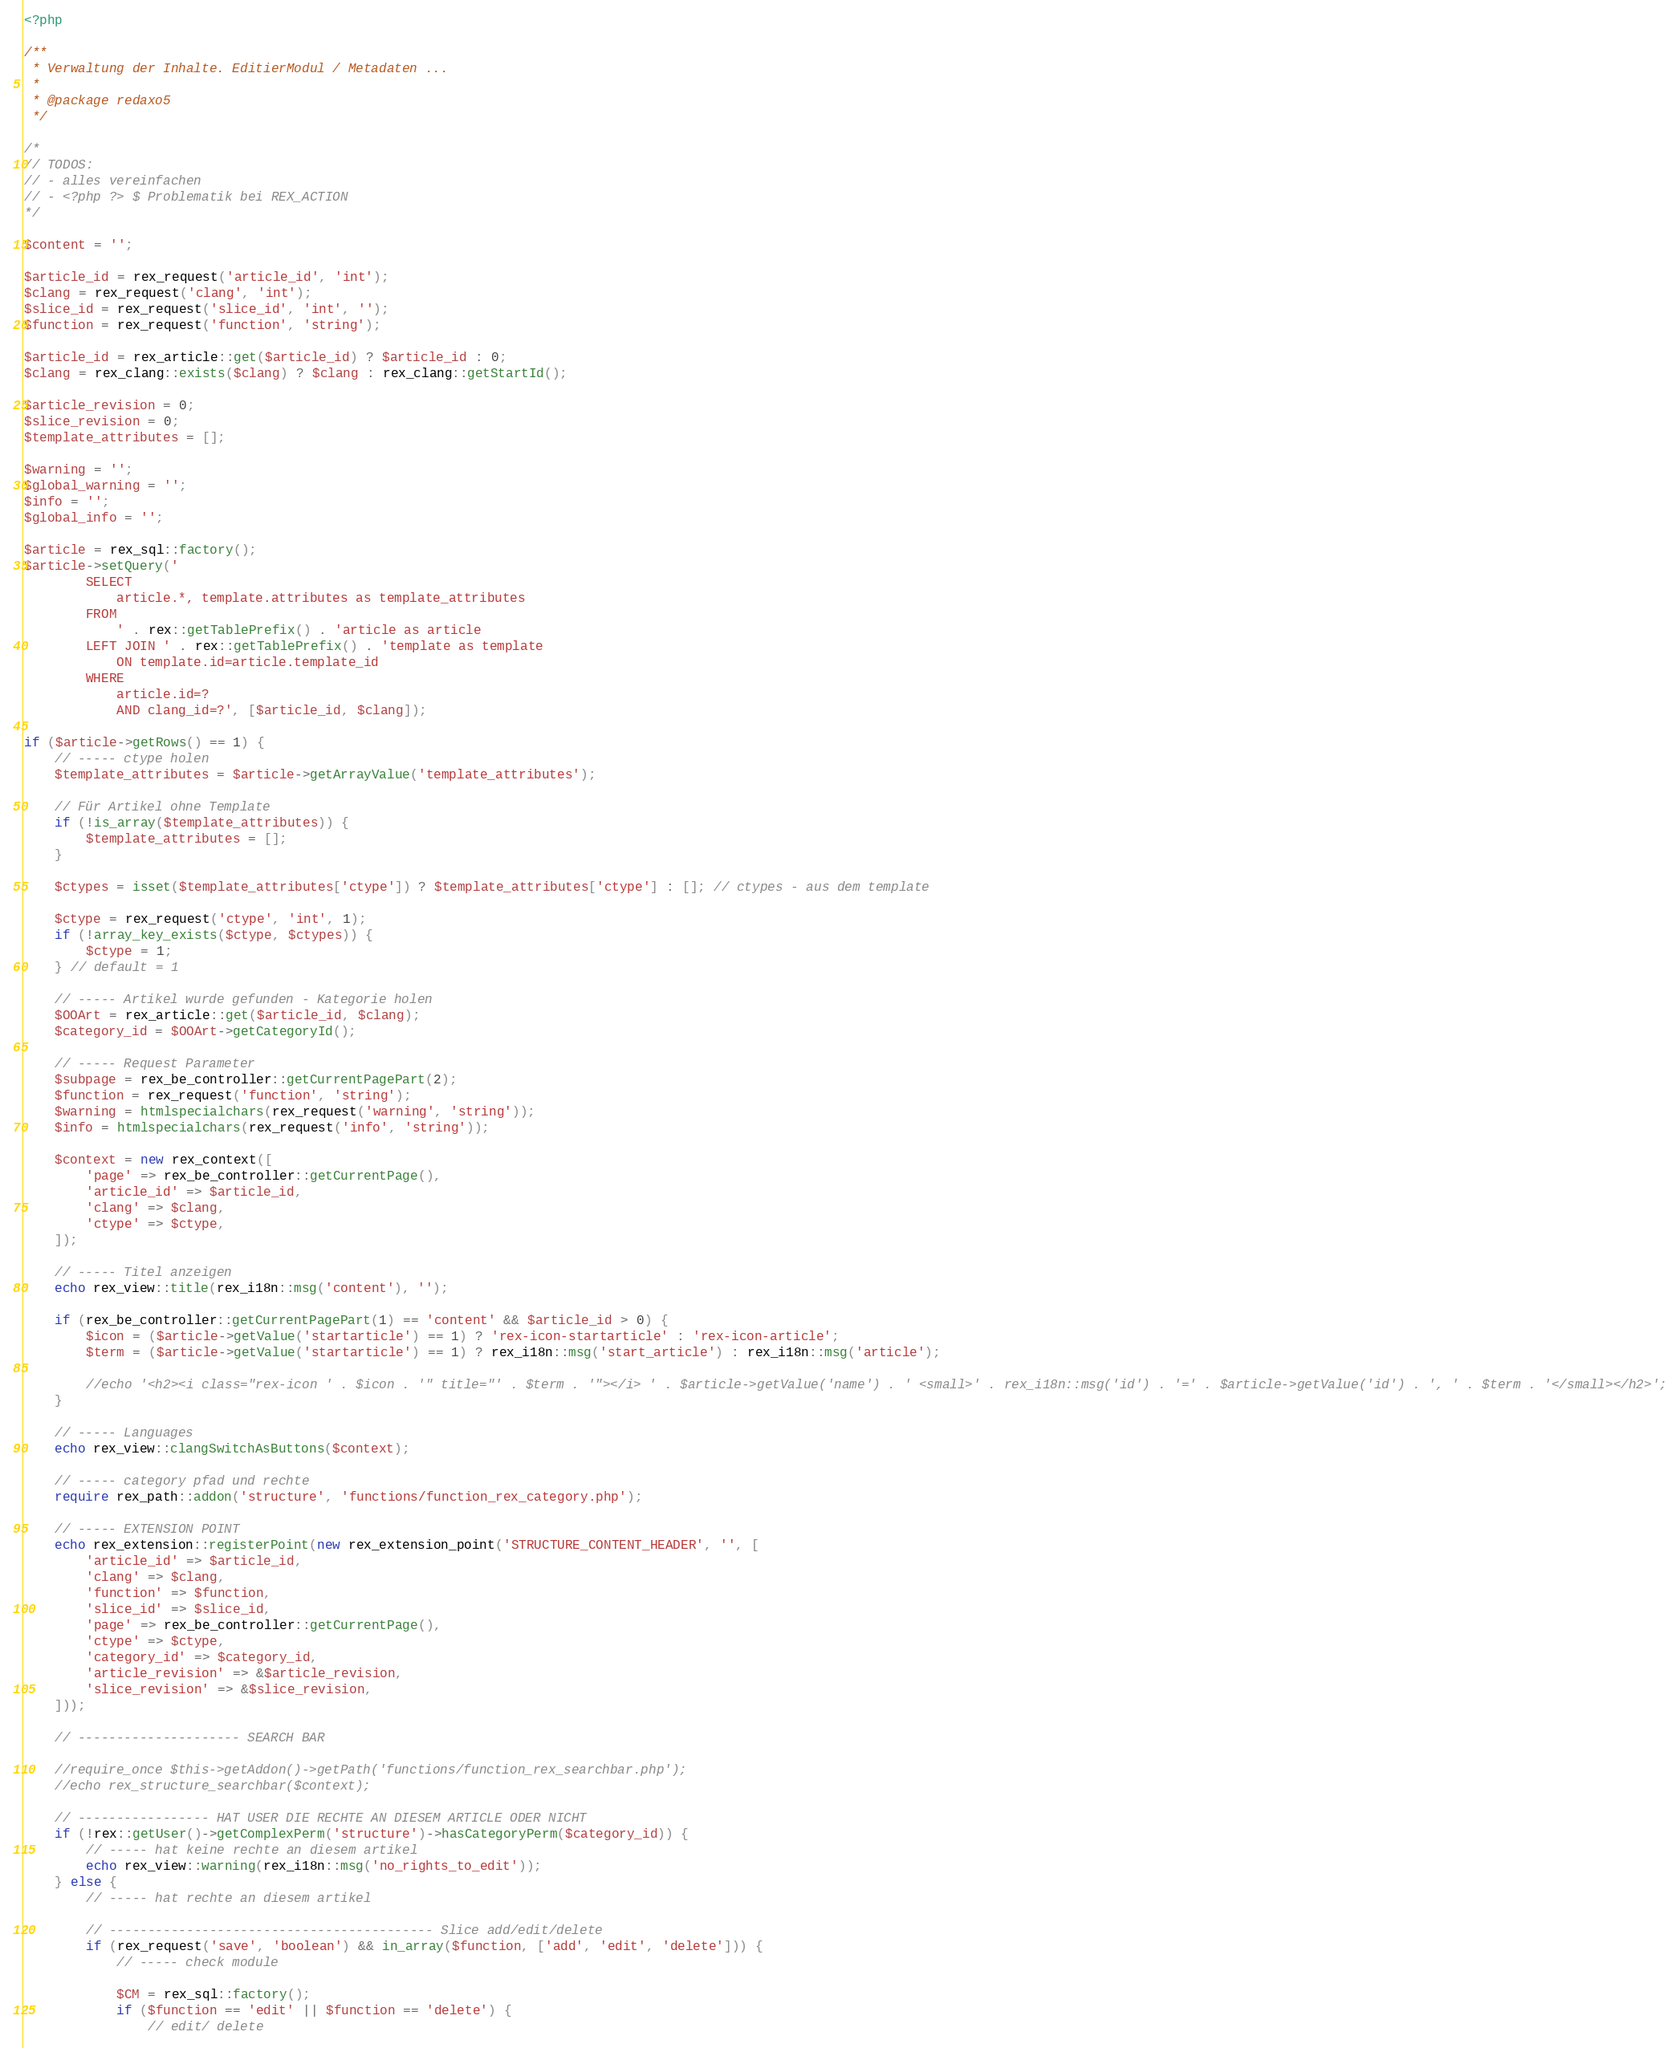Convert code to text. <code><loc_0><loc_0><loc_500><loc_500><_PHP_><?php

/**
 * Verwaltung der Inhalte. EditierModul / Metadaten ...
 *
 * @package redaxo5
 */

/*
// TODOS:
// - alles vereinfachen
// - <?php ?> $ Problematik bei REX_ACTION
*/

$content = '';

$article_id = rex_request('article_id', 'int');
$clang = rex_request('clang', 'int');
$slice_id = rex_request('slice_id', 'int', '');
$function = rex_request('function', 'string');

$article_id = rex_article::get($article_id) ? $article_id : 0;
$clang = rex_clang::exists($clang) ? $clang : rex_clang::getStartId();

$article_revision = 0;
$slice_revision = 0;
$template_attributes = [];

$warning = '';
$global_warning = '';
$info = '';
$global_info = '';

$article = rex_sql::factory();
$article->setQuery('
        SELECT
            article.*, template.attributes as template_attributes
        FROM
            ' . rex::getTablePrefix() . 'article as article
        LEFT JOIN ' . rex::getTablePrefix() . 'template as template
            ON template.id=article.template_id
        WHERE
            article.id=?
            AND clang_id=?', [$article_id, $clang]);

if ($article->getRows() == 1) {
    // ----- ctype holen
    $template_attributes = $article->getArrayValue('template_attributes');

    // Für Artikel ohne Template
    if (!is_array($template_attributes)) {
        $template_attributes = [];
    }

    $ctypes = isset($template_attributes['ctype']) ? $template_attributes['ctype'] : []; // ctypes - aus dem template

    $ctype = rex_request('ctype', 'int', 1);
    if (!array_key_exists($ctype, $ctypes)) {
        $ctype = 1;
    } // default = 1

    // ----- Artikel wurde gefunden - Kategorie holen
    $OOArt = rex_article::get($article_id, $clang);
    $category_id = $OOArt->getCategoryId();

    // ----- Request Parameter
    $subpage = rex_be_controller::getCurrentPagePart(2);
    $function = rex_request('function', 'string');
    $warning = htmlspecialchars(rex_request('warning', 'string'));
    $info = htmlspecialchars(rex_request('info', 'string'));

    $context = new rex_context([
        'page' => rex_be_controller::getCurrentPage(),
        'article_id' => $article_id,
        'clang' => $clang,
        'ctype' => $ctype,
    ]);

    // ----- Titel anzeigen
    echo rex_view::title(rex_i18n::msg('content'), '');

    if (rex_be_controller::getCurrentPagePart(1) == 'content' && $article_id > 0) {
        $icon = ($article->getValue('startarticle') == 1) ? 'rex-icon-startarticle' : 'rex-icon-article';
        $term = ($article->getValue('startarticle') == 1) ? rex_i18n::msg('start_article') : rex_i18n::msg('article');

        //echo '<h2><i class="rex-icon ' . $icon . '" title="' . $term . '"></i> ' . $article->getValue('name') . ' <small>' . rex_i18n::msg('id') . '=' . $article->getValue('id') . ', ' . $term . '</small></h2>';
    }

    // ----- Languages
    echo rex_view::clangSwitchAsButtons($context);

    // ----- category pfad und rechte
    require rex_path::addon('structure', 'functions/function_rex_category.php');

    // ----- EXTENSION POINT
    echo rex_extension::registerPoint(new rex_extension_point('STRUCTURE_CONTENT_HEADER', '', [
        'article_id' => $article_id,
        'clang' => $clang,
        'function' => $function,
        'slice_id' => $slice_id,
        'page' => rex_be_controller::getCurrentPage(),
        'ctype' => $ctype,
        'category_id' => $category_id,
        'article_revision' => &$article_revision,
        'slice_revision' => &$slice_revision,
    ]));

    // --------------------- SEARCH BAR

    //require_once $this->getAddon()->getPath('functions/function_rex_searchbar.php');
    //echo rex_structure_searchbar($context);

    // ----------------- HAT USER DIE RECHTE AN DIESEM ARTICLE ODER NICHT
    if (!rex::getUser()->getComplexPerm('structure')->hasCategoryPerm($category_id)) {
        // ----- hat keine rechte an diesem artikel
        echo rex_view::warning(rex_i18n::msg('no_rights_to_edit'));
    } else {
        // ----- hat rechte an diesem artikel

        // ------------------------------------------ Slice add/edit/delete
        if (rex_request('save', 'boolean') && in_array($function, ['add', 'edit', 'delete'])) {
            // ----- check module

            $CM = rex_sql::factory();
            if ($function == 'edit' || $function == 'delete') {
                // edit/ delete</code> 